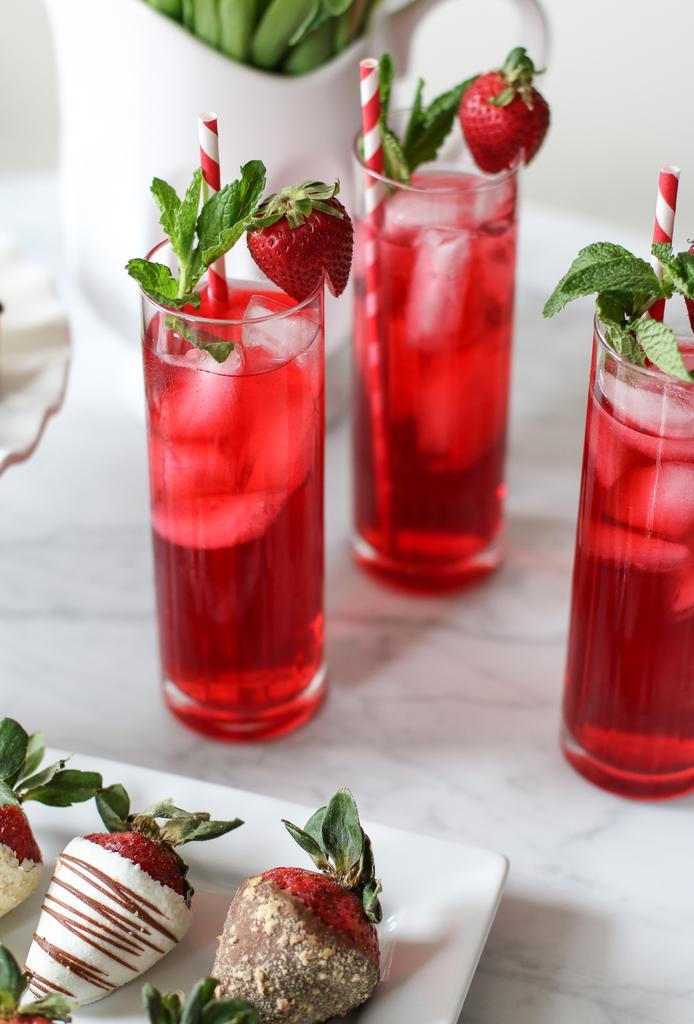Please provide a concise description of this image. There are some objects on the white color plate, which is on the table, on which, there are glasses filled with juice and there are other objects, near white wall. 